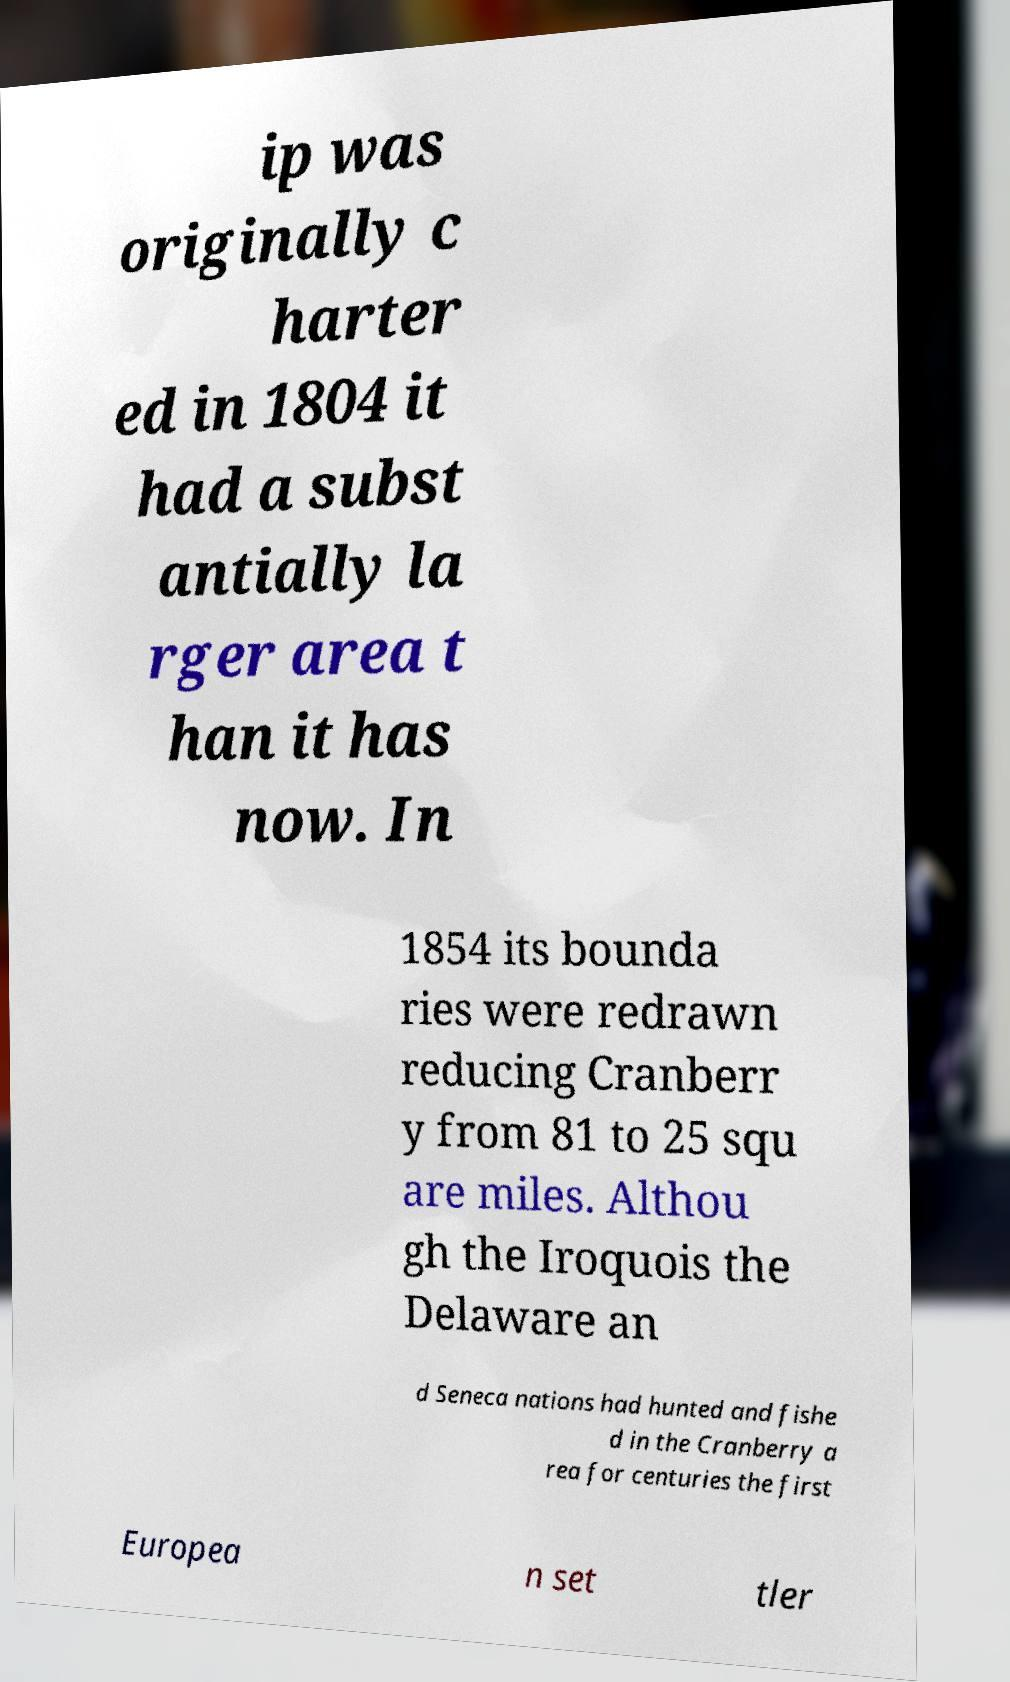For documentation purposes, I need the text within this image transcribed. Could you provide that? ip was originally c harter ed in 1804 it had a subst antially la rger area t han it has now. In 1854 its bounda ries were redrawn reducing Cranberr y from 81 to 25 squ are miles. Althou gh the Iroquois the Delaware an d Seneca nations had hunted and fishe d in the Cranberry a rea for centuries the first Europea n set tler 